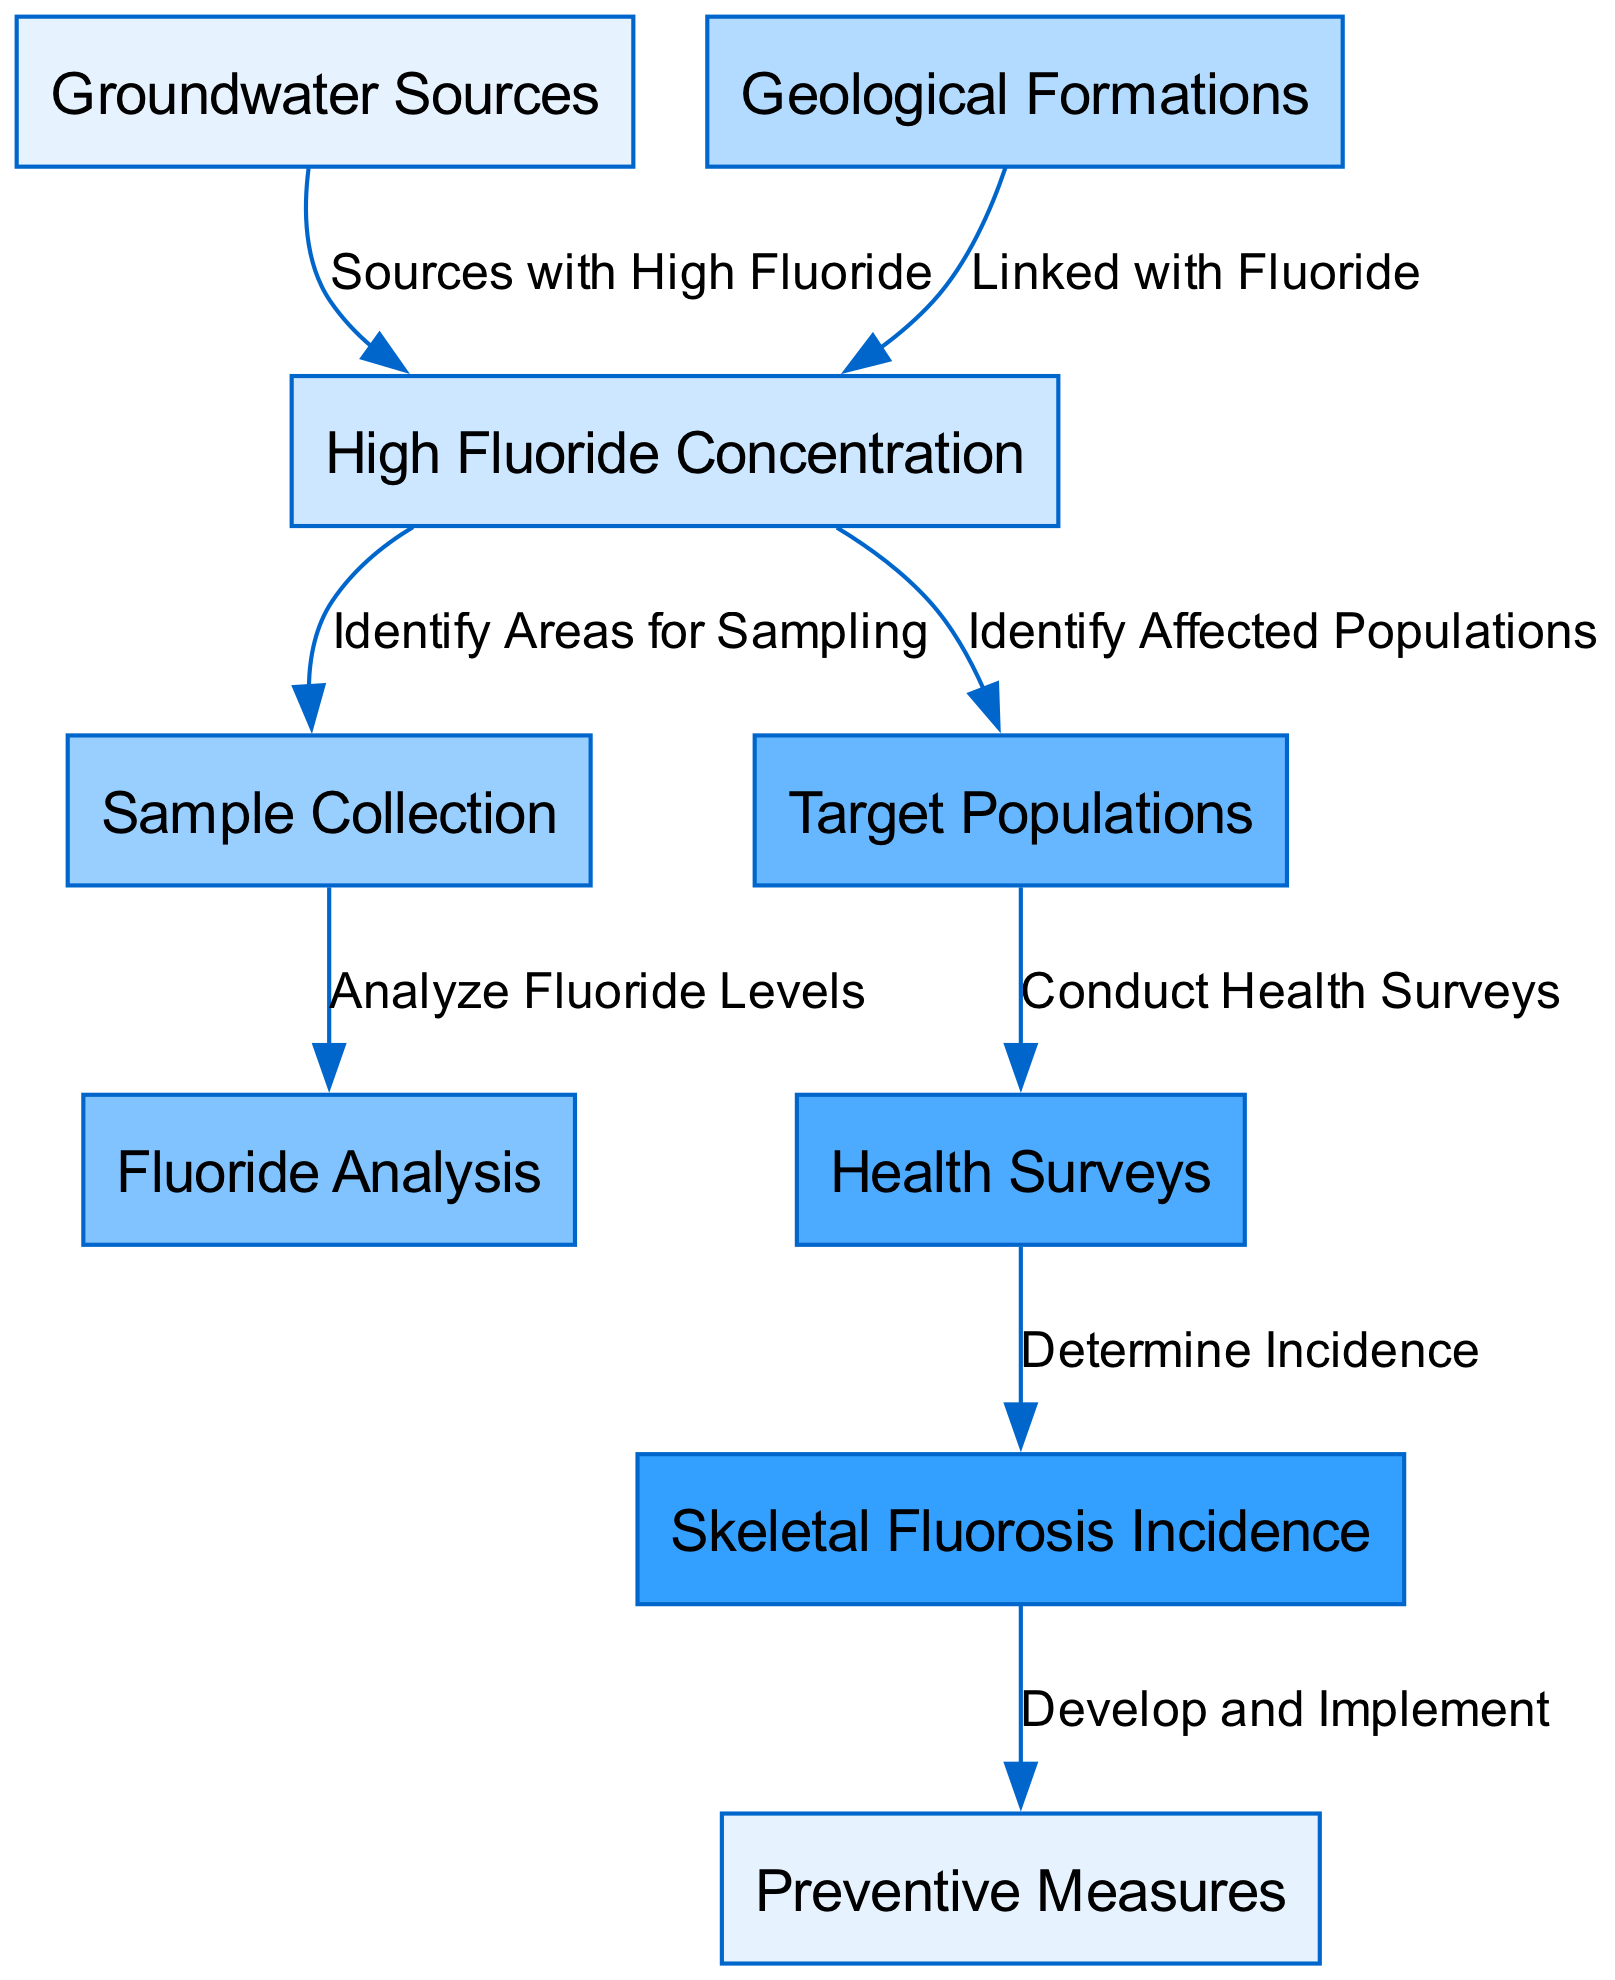What are the sources of high fluoride concentration? The diagram indicates that "Groundwater Sources" is connected to "High Fluoride Concentration," implying that groundwater sources are the sources of high fluoride levels.
Answer: Groundwater Sources How many nodes are in the diagram? The diagram contains a total of 9 nodes, which represent different aspects of the study related to skeletal fluorosis.
Answer: 9 Which node directly follows "Sample Collection"? According to the diagram, "Fluoride Analysis" directly follows the "Sample Collection" node, indicating the next step after gathering samples.
Answer: Fluoride Analysis What leads to the determination of skeletal fluorosis incidence? The diagram shows a flow from "Health Surveys" to "Skeletal Fluorosis Incidence," indicating that conducting health surveys leads to determining the incidence of skeletal fluorosis.
Answer: Health Surveys What action is taken after determining skeletal fluorosis incidence? After determining skeletal fluorosis incidence, the diagram indicates that "Preventive Measures" are developed and implemented as a follow-up action.
Answer: Preventive Measures What type of populations are identified in the study? The diagram specifies "Target Populations" as the type of populations that are identified in connection with high fluoride concentration.
Answer: Target Populations How is skeletal fluorosis incidence assessed? The diagram outlines that skeletal fluorosis incidence is assessed through the node "Health Surveys," which contributes data for this assessment.
Answer: Health Surveys Which geological aspect influences high fluoride concentration? The diagram highlights that "Geological Formations" are linked with "High Fluoride Concentration," indicating their influence on fluoride levels.
Answer: Geological Formations What is the sequence of actions starting from high fluoride concentration? The sequence of actions begins at "High Fluoride Concentration," followed by identifying areas for sampling, conducting sample collection, and then performing fluoride analysis.
Answer: Identify Areas for Sampling, Sample Collection, Fluoride Analysis 